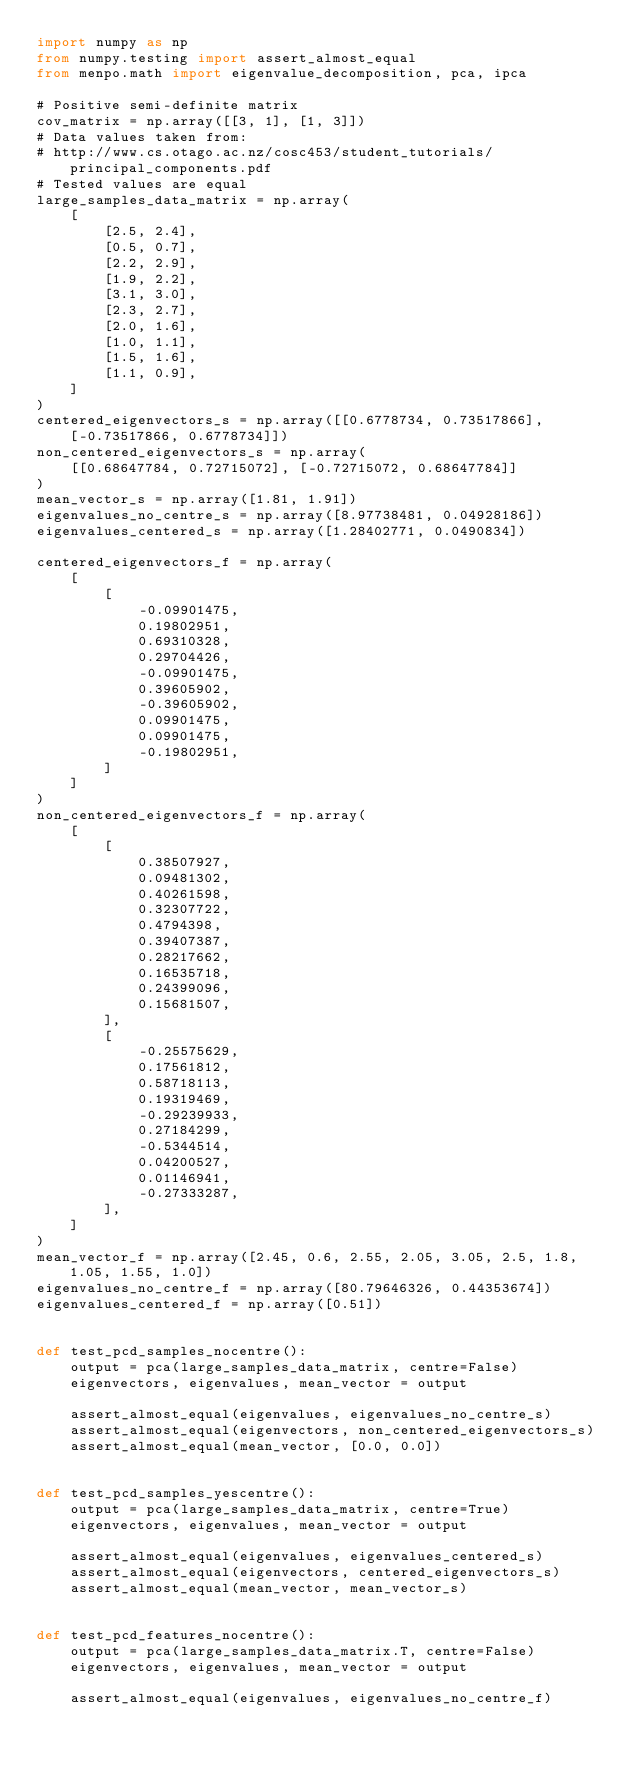<code> <loc_0><loc_0><loc_500><loc_500><_Python_>import numpy as np
from numpy.testing import assert_almost_equal
from menpo.math import eigenvalue_decomposition, pca, ipca

# Positive semi-definite matrix
cov_matrix = np.array([[3, 1], [1, 3]])
# Data values taken from:
# http://www.cs.otago.ac.nz/cosc453/student_tutorials/principal_components.pdf
# Tested values are equal
large_samples_data_matrix = np.array(
    [
        [2.5, 2.4],
        [0.5, 0.7],
        [2.2, 2.9],
        [1.9, 2.2],
        [3.1, 3.0],
        [2.3, 2.7],
        [2.0, 1.6],
        [1.0, 1.1],
        [1.5, 1.6],
        [1.1, 0.9],
    ]
)
centered_eigenvectors_s = np.array([[0.6778734, 0.73517866], [-0.73517866, 0.6778734]])
non_centered_eigenvectors_s = np.array(
    [[0.68647784, 0.72715072], [-0.72715072, 0.68647784]]
)
mean_vector_s = np.array([1.81, 1.91])
eigenvalues_no_centre_s = np.array([8.97738481, 0.04928186])
eigenvalues_centered_s = np.array([1.28402771, 0.0490834])

centered_eigenvectors_f = np.array(
    [
        [
            -0.09901475,
            0.19802951,
            0.69310328,
            0.29704426,
            -0.09901475,
            0.39605902,
            -0.39605902,
            0.09901475,
            0.09901475,
            -0.19802951,
        ]
    ]
)
non_centered_eigenvectors_f = np.array(
    [
        [
            0.38507927,
            0.09481302,
            0.40261598,
            0.32307722,
            0.4794398,
            0.39407387,
            0.28217662,
            0.16535718,
            0.24399096,
            0.15681507,
        ],
        [
            -0.25575629,
            0.17561812,
            0.58718113,
            0.19319469,
            -0.29239933,
            0.27184299,
            -0.5344514,
            0.04200527,
            0.01146941,
            -0.27333287,
        ],
    ]
)
mean_vector_f = np.array([2.45, 0.6, 2.55, 2.05, 3.05, 2.5, 1.8, 1.05, 1.55, 1.0])
eigenvalues_no_centre_f = np.array([80.79646326, 0.44353674])
eigenvalues_centered_f = np.array([0.51])


def test_pcd_samples_nocentre():
    output = pca(large_samples_data_matrix, centre=False)
    eigenvectors, eigenvalues, mean_vector = output

    assert_almost_equal(eigenvalues, eigenvalues_no_centre_s)
    assert_almost_equal(eigenvectors, non_centered_eigenvectors_s)
    assert_almost_equal(mean_vector, [0.0, 0.0])


def test_pcd_samples_yescentre():
    output = pca(large_samples_data_matrix, centre=True)
    eigenvectors, eigenvalues, mean_vector = output

    assert_almost_equal(eigenvalues, eigenvalues_centered_s)
    assert_almost_equal(eigenvectors, centered_eigenvectors_s)
    assert_almost_equal(mean_vector, mean_vector_s)


def test_pcd_features_nocentre():
    output = pca(large_samples_data_matrix.T, centre=False)
    eigenvectors, eigenvalues, mean_vector = output

    assert_almost_equal(eigenvalues, eigenvalues_no_centre_f)</code> 